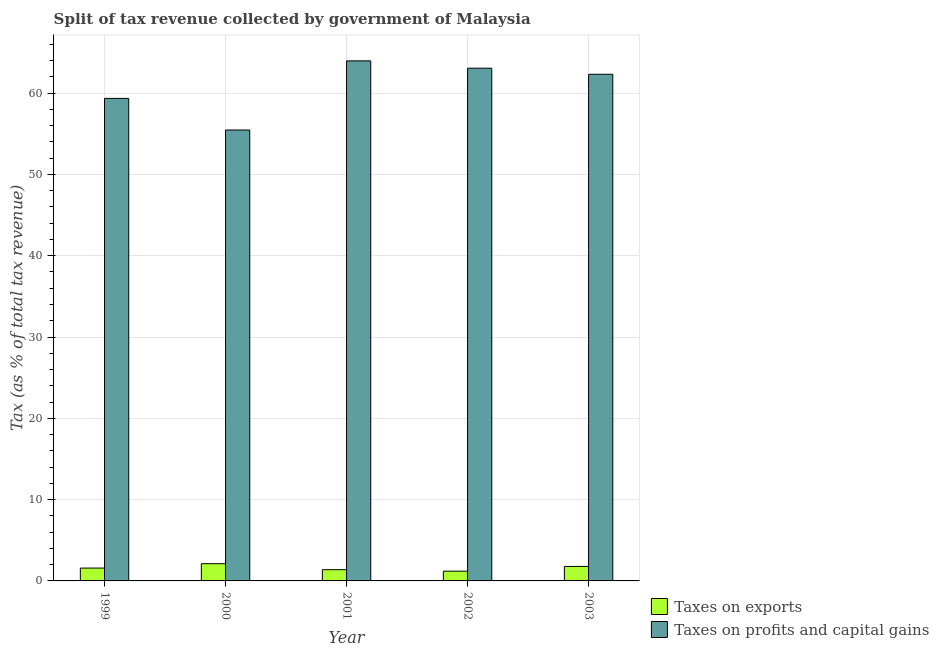How many different coloured bars are there?
Ensure brevity in your answer.  2. How many groups of bars are there?
Ensure brevity in your answer.  5. What is the label of the 3rd group of bars from the left?
Ensure brevity in your answer.  2001. In how many cases, is the number of bars for a given year not equal to the number of legend labels?
Provide a short and direct response. 0. What is the percentage of revenue obtained from taxes on exports in 2003?
Your answer should be compact. 1.78. Across all years, what is the maximum percentage of revenue obtained from taxes on profits and capital gains?
Provide a short and direct response. 63.97. Across all years, what is the minimum percentage of revenue obtained from taxes on profits and capital gains?
Make the answer very short. 55.46. In which year was the percentage of revenue obtained from taxes on profits and capital gains maximum?
Offer a terse response. 2001. What is the total percentage of revenue obtained from taxes on profits and capital gains in the graph?
Your response must be concise. 304.17. What is the difference between the percentage of revenue obtained from taxes on profits and capital gains in 2001 and that in 2002?
Your answer should be compact. 0.9. What is the difference between the percentage of revenue obtained from taxes on profits and capital gains in 2001 and the percentage of revenue obtained from taxes on exports in 1999?
Offer a very short reply. 4.61. What is the average percentage of revenue obtained from taxes on profits and capital gains per year?
Provide a succinct answer. 60.83. In the year 2002, what is the difference between the percentage of revenue obtained from taxes on exports and percentage of revenue obtained from taxes on profits and capital gains?
Keep it short and to the point. 0. In how many years, is the percentage of revenue obtained from taxes on exports greater than 2 %?
Offer a very short reply. 1. What is the ratio of the percentage of revenue obtained from taxes on exports in 2001 to that in 2002?
Make the answer very short. 1.15. Is the percentage of revenue obtained from taxes on exports in 1999 less than that in 2003?
Provide a short and direct response. Yes. What is the difference between the highest and the second highest percentage of revenue obtained from taxes on profits and capital gains?
Offer a terse response. 0.9. What is the difference between the highest and the lowest percentage of revenue obtained from taxes on exports?
Provide a short and direct response. 0.92. Is the sum of the percentage of revenue obtained from taxes on exports in 1999 and 2001 greater than the maximum percentage of revenue obtained from taxes on profits and capital gains across all years?
Provide a succinct answer. Yes. What does the 1st bar from the left in 2000 represents?
Your answer should be compact. Taxes on exports. What does the 1st bar from the right in 1999 represents?
Ensure brevity in your answer.  Taxes on profits and capital gains. How many bars are there?
Your answer should be very brief. 10. Are all the bars in the graph horizontal?
Your answer should be very brief. No. What is the difference between two consecutive major ticks on the Y-axis?
Ensure brevity in your answer.  10. Are the values on the major ticks of Y-axis written in scientific E-notation?
Provide a succinct answer. No. Does the graph contain any zero values?
Provide a short and direct response. No. What is the title of the graph?
Your answer should be very brief. Split of tax revenue collected by government of Malaysia. Does "ODA received" appear as one of the legend labels in the graph?
Offer a very short reply. No. What is the label or title of the Y-axis?
Offer a very short reply. Tax (as % of total tax revenue). What is the Tax (as % of total tax revenue) in Taxes on exports in 1999?
Provide a short and direct response. 1.58. What is the Tax (as % of total tax revenue) in Taxes on profits and capital gains in 1999?
Provide a short and direct response. 59.35. What is the Tax (as % of total tax revenue) of Taxes on exports in 2000?
Ensure brevity in your answer.  2.12. What is the Tax (as % of total tax revenue) in Taxes on profits and capital gains in 2000?
Provide a short and direct response. 55.46. What is the Tax (as % of total tax revenue) of Taxes on exports in 2001?
Provide a succinct answer. 1.38. What is the Tax (as % of total tax revenue) in Taxes on profits and capital gains in 2001?
Make the answer very short. 63.97. What is the Tax (as % of total tax revenue) in Taxes on exports in 2002?
Provide a short and direct response. 1.2. What is the Tax (as % of total tax revenue) in Taxes on profits and capital gains in 2002?
Offer a very short reply. 63.07. What is the Tax (as % of total tax revenue) in Taxes on exports in 2003?
Offer a very short reply. 1.78. What is the Tax (as % of total tax revenue) in Taxes on profits and capital gains in 2003?
Make the answer very short. 62.32. Across all years, what is the maximum Tax (as % of total tax revenue) in Taxes on exports?
Provide a short and direct response. 2.12. Across all years, what is the maximum Tax (as % of total tax revenue) in Taxes on profits and capital gains?
Give a very brief answer. 63.97. Across all years, what is the minimum Tax (as % of total tax revenue) of Taxes on exports?
Provide a succinct answer. 1.2. Across all years, what is the minimum Tax (as % of total tax revenue) of Taxes on profits and capital gains?
Offer a terse response. 55.46. What is the total Tax (as % of total tax revenue) in Taxes on exports in the graph?
Ensure brevity in your answer.  8.06. What is the total Tax (as % of total tax revenue) in Taxes on profits and capital gains in the graph?
Provide a short and direct response. 304.17. What is the difference between the Tax (as % of total tax revenue) in Taxes on exports in 1999 and that in 2000?
Provide a succinct answer. -0.54. What is the difference between the Tax (as % of total tax revenue) in Taxes on profits and capital gains in 1999 and that in 2000?
Offer a terse response. 3.89. What is the difference between the Tax (as % of total tax revenue) of Taxes on exports in 1999 and that in 2001?
Provide a succinct answer. 0.2. What is the difference between the Tax (as % of total tax revenue) in Taxes on profits and capital gains in 1999 and that in 2001?
Offer a terse response. -4.61. What is the difference between the Tax (as % of total tax revenue) of Taxes on exports in 1999 and that in 2002?
Make the answer very short. 0.38. What is the difference between the Tax (as % of total tax revenue) in Taxes on profits and capital gains in 1999 and that in 2002?
Provide a succinct answer. -3.72. What is the difference between the Tax (as % of total tax revenue) in Taxes on exports in 1999 and that in 2003?
Give a very brief answer. -0.2. What is the difference between the Tax (as % of total tax revenue) in Taxes on profits and capital gains in 1999 and that in 2003?
Your response must be concise. -2.97. What is the difference between the Tax (as % of total tax revenue) of Taxes on exports in 2000 and that in 2001?
Your response must be concise. 0.74. What is the difference between the Tax (as % of total tax revenue) in Taxes on profits and capital gains in 2000 and that in 2001?
Offer a terse response. -8.5. What is the difference between the Tax (as % of total tax revenue) in Taxes on exports in 2000 and that in 2002?
Ensure brevity in your answer.  0.92. What is the difference between the Tax (as % of total tax revenue) of Taxes on profits and capital gains in 2000 and that in 2002?
Make the answer very short. -7.6. What is the difference between the Tax (as % of total tax revenue) of Taxes on exports in 2000 and that in 2003?
Keep it short and to the point. 0.34. What is the difference between the Tax (as % of total tax revenue) of Taxes on profits and capital gains in 2000 and that in 2003?
Give a very brief answer. -6.86. What is the difference between the Tax (as % of total tax revenue) in Taxes on exports in 2001 and that in 2002?
Your answer should be very brief. 0.18. What is the difference between the Tax (as % of total tax revenue) of Taxes on profits and capital gains in 2001 and that in 2002?
Ensure brevity in your answer.  0.9. What is the difference between the Tax (as % of total tax revenue) in Taxes on exports in 2001 and that in 2003?
Your answer should be compact. -0.4. What is the difference between the Tax (as % of total tax revenue) of Taxes on profits and capital gains in 2001 and that in 2003?
Give a very brief answer. 1.65. What is the difference between the Tax (as % of total tax revenue) of Taxes on exports in 2002 and that in 2003?
Offer a terse response. -0.58. What is the difference between the Tax (as % of total tax revenue) in Taxes on profits and capital gains in 2002 and that in 2003?
Ensure brevity in your answer.  0.75. What is the difference between the Tax (as % of total tax revenue) of Taxes on exports in 1999 and the Tax (as % of total tax revenue) of Taxes on profits and capital gains in 2000?
Provide a succinct answer. -53.88. What is the difference between the Tax (as % of total tax revenue) of Taxes on exports in 1999 and the Tax (as % of total tax revenue) of Taxes on profits and capital gains in 2001?
Provide a short and direct response. -62.39. What is the difference between the Tax (as % of total tax revenue) in Taxes on exports in 1999 and the Tax (as % of total tax revenue) in Taxes on profits and capital gains in 2002?
Keep it short and to the point. -61.49. What is the difference between the Tax (as % of total tax revenue) in Taxes on exports in 1999 and the Tax (as % of total tax revenue) in Taxes on profits and capital gains in 2003?
Offer a very short reply. -60.74. What is the difference between the Tax (as % of total tax revenue) in Taxes on exports in 2000 and the Tax (as % of total tax revenue) in Taxes on profits and capital gains in 2001?
Keep it short and to the point. -61.85. What is the difference between the Tax (as % of total tax revenue) of Taxes on exports in 2000 and the Tax (as % of total tax revenue) of Taxes on profits and capital gains in 2002?
Keep it short and to the point. -60.95. What is the difference between the Tax (as % of total tax revenue) in Taxes on exports in 2000 and the Tax (as % of total tax revenue) in Taxes on profits and capital gains in 2003?
Ensure brevity in your answer.  -60.2. What is the difference between the Tax (as % of total tax revenue) of Taxes on exports in 2001 and the Tax (as % of total tax revenue) of Taxes on profits and capital gains in 2002?
Provide a short and direct response. -61.69. What is the difference between the Tax (as % of total tax revenue) of Taxes on exports in 2001 and the Tax (as % of total tax revenue) of Taxes on profits and capital gains in 2003?
Your response must be concise. -60.94. What is the difference between the Tax (as % of total tax revenue) of Taxes on exports in 2002 and the Tax (as % of total tax revenue) of Taxes on profits and capital gains in 2003?
Offer a very short reply. -61.12. What is the average Tax (as % of total tax revenue) of Taxes on exports per year?
Offer a very short reply. 1.61. What is the average Tax (as % of total tax revenue) of Taxes on profits and capital gains per year?
Your answer should be compact. 60.83. In the year 1999, what is the difference between the Tax (as % of total tax revenue) in Taxes on exports and Tax (as % of total tax revenue) in Taxes on profits and capital gains?
Ensure brevity in your answer.  -57.77. In the year 2000, what is the difference between the Tax (as % of total tax revenue) in Taxes on exports and Tax (as % of total tax revenue) in Taxes on profits and capital gains?
Offer a very short reply. -53.34. In the year 2001, what is the difference between the Tax (as % of total tax revenue) of Taxes on exports and Tax (as % of total tax revenue) of Taxes on profits and capital gains?
Your answer should be very brief. -62.59. In the year 2002, what is the difference between the Tax (as % of total tax revenue) in Taxes on exports and Tax (as % of total tax revenue) in Taxes on profits and capital gains?
Provide a succinct answer. -61.87. In the year 2003, what is the difference between the Tax (as % of total tax revenue) of Taxes on exports and Tax (as % of total tax revenue) of Taxes on profits and capital gains?
Your response must be concise. -60.54. What is the ratio of the Tax (as % of total tax revenue) of Taxes on exports in 1999 to that in 2000?
Give a very brief answer. 0.75. What is the ratio of the Tax (as % of total tax revenue) in Taxes on profits and capital gains in 1999 to that in 2000?
Your answer should be very brief. 1.07. What is the ratio of the Tax (as % of total tax revenue) in Taxes on exports in 1999 to that in 2001?
Your response must be concise. 1.14. What is the ratio of the Tax (as % of total tax revenue) in Taxes on profits and capital gains in 1999 to that in 2001?
Offer a terse response. 0.93. What is the ratio of the Tax (as % of total tax revenue) in Taxes on exports in 1999 to that in 2002?
Ensure brevity in your answer.  1.32. What is the ratio of the Tax (as % of total tax revenue) in Taxes on profits and capital gains in 1999 to that in 2002?
Offer a very short reply. 0.94. What is the ratio of the Tax (as % of total tax revenue) of Taxes on exports in 1999 to that in 2003?
Offer a very short reply. 0.89. What is the ratio of the Tax (as % of total tax revenue) of Taxes on profits and capital gains in 1999 to that in 2003?
Your response must be concise. 0.95. What is the ratio of the Tax (as % of total tax revenue) in Taxes on exports in 2000 to that in 2001?
Give a very brief answer. 1.53. What is the ratio of the Tax (as % of total tax revenue) of Taxes on profits and capital gains in 2000 to that in 2001?
Your answer should be very brief. 0.87. What is the ratio of the Tax (as % of total tax revenue) in Taxes on exports in 2000 to that in 2002?
Your response must be concise. 1.76. What is the ratio of the Tax (as % of total tax revenue) of Taxes on profits and capital gains in 2000 to that in 2002?
Your answer should be very brief. 0.88. What is the ratio of the Tax (as % of total tax revenue) of Taxes on exports in 2000 to that in 2003?
Offer a terse response. 1.19. What is the ratio of the Tax (as % of total tax revenue) of Taxes on profits and capital gains in 2000 to that in 2003?
Make the answer very short. 0.89. What is the ratio of the Tax (as % of total tax revenue) in Taxes on exports in 2001 to that in 2002?
Make the answer very short. 1.15. What is the ratio of the Tax (as % of total tax revenue) in Taxes on profits and capital gains in 2001 to that in 2002?
Provide a succinct answer. 1.01. What is the ratio of the Tax (as % of total tax revenue) of Taxes on exports in 2001 to that in 2003?
Provide a short and direct response. 0.78. What is the ratio of the Tax (as % of total tax revenue) of Taxes on profits and capital gains in 2001 to that in 2003?
Ensure brevity in your answer.  1.03. What is the ratio of the Tax (as % of total tax revenue) in Taxes on exports in 2002 to that in 2003?
Your answer should be compact. 0.67. What is the difference between the highest and the second highest Tax (as % of total tax revenue) in Taxes on exports?
Ensure brevity in your answer.  0.34. What is the difference between the highest and the second highest Tax (as % of total tax revenue) in Taxes on profits and capital gains?
Make the answer very short. 0.9. What is the difference between the highest and the lowest Tax (as % of total tax revenue) in Taxes on exports?
Offer a very short reply. 0.92. What is the difference between the highest and the lowest Tax (as % of total tax revenue) of Taxes on profits and capital gains?
Ensure brevity in your answer.  8.5. 